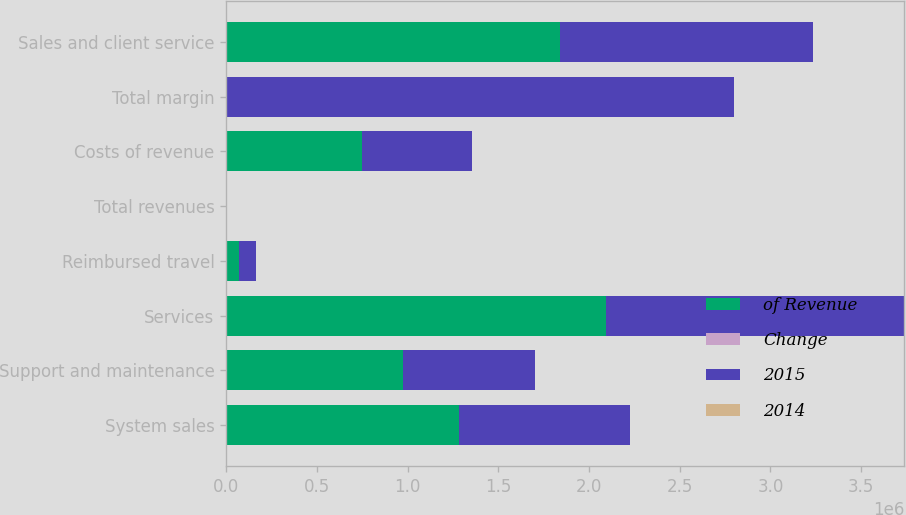<chart> <loc_0><loc_0><loc_500><loc_500><stacked_bar_chart><ecel><fcel>System sales<fcel>Support and maintenance<fcel>Services<fcel>Reimbursed travel<fcel>Total revenues<fcel>Costs of revenue<fcel>Total margin<fcel>Sales and client service<nl><fcel>of Revenue<fcel>1.28189e+06<fcel>975701<fcel>2.09487e+06<fcel>72802<fcel>83<fcel>750781<fcel>83<fcel>1.8386e+06<nl><fcel>Change<fcel>29<fcel>22<fcel>47<fcel>2<fcel>100<fcel>17<fcel>83<fcel>42<nl><fcel>2015<fcel>945858<fcel>724840<fcel>1.64212e+06<fcel>89886<fcel>83<fcel>604377<fcel>2.79833e+06<fcel>1.39557e+06<nl><fcel>2014<fcel>36<fcel>35<fcel>28<fcel>19<fcel>30<fcel>24<fcel>31<fcel>32<nl></chart> 